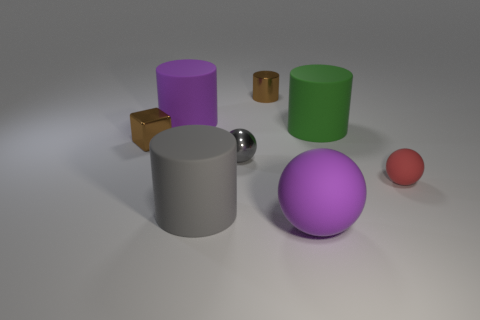Subtract all gray metal spheres. How many spheres are left? 2 Add 1 small brown cylinders. How many objects exist? 9 Subtract all spheres. How many objects are left? 5 Subtract 2 cylinders. How many cylinders are left? 2 Subtract all small metal spheres. Subtract all big purple things. How many objects are left? 5 Add 5 spheres. How many spheres are left? 8 Add 3 small brown objects. How many small brown objects exist? 5 Subtract all green cylinders. How many cylinders are left? 3 Subtract 1 gray cylinders. How many objects are left? 7 Subtract all gray blocks. Subtract all gray balls. How many blocks are left? 1 